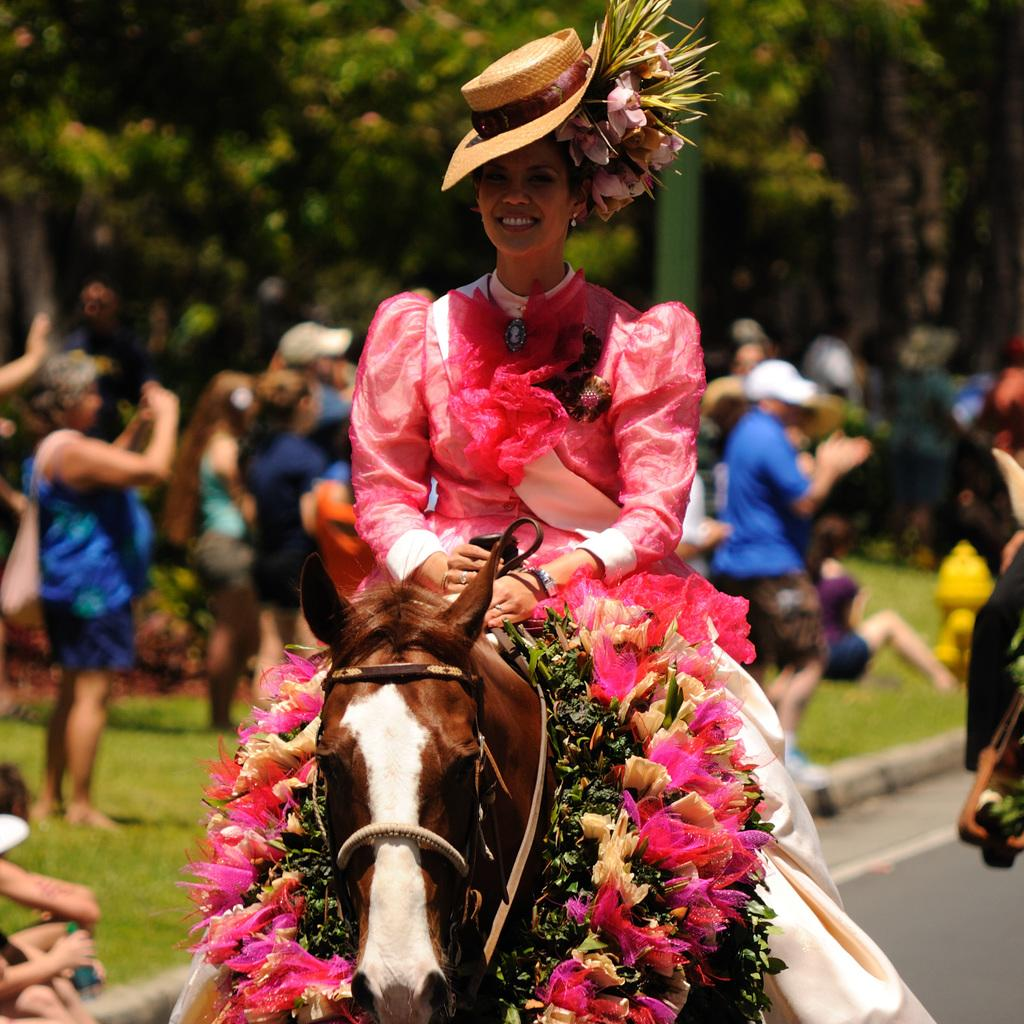Who is the main subject in the image? There is a woman in the image. What is the woman doing in the image? The woman is sitting on a horse. Can you describe the background of the image? There are people visible in the background of the image. What type of reward is the horse receiving in the image? There is no indication in the image that the horse is receiving a reward, so it cannot be determined from the picture. 